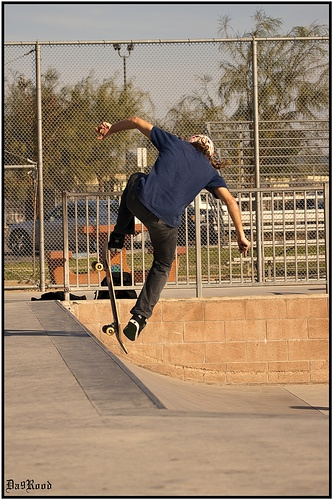Describe the objects in this image and their specific colors. I can see people in white, black, maroon, and gray tones, car in white, gray, and black tones, and skateboard in white, black, maroon, khaki, and gray tones in this image. 